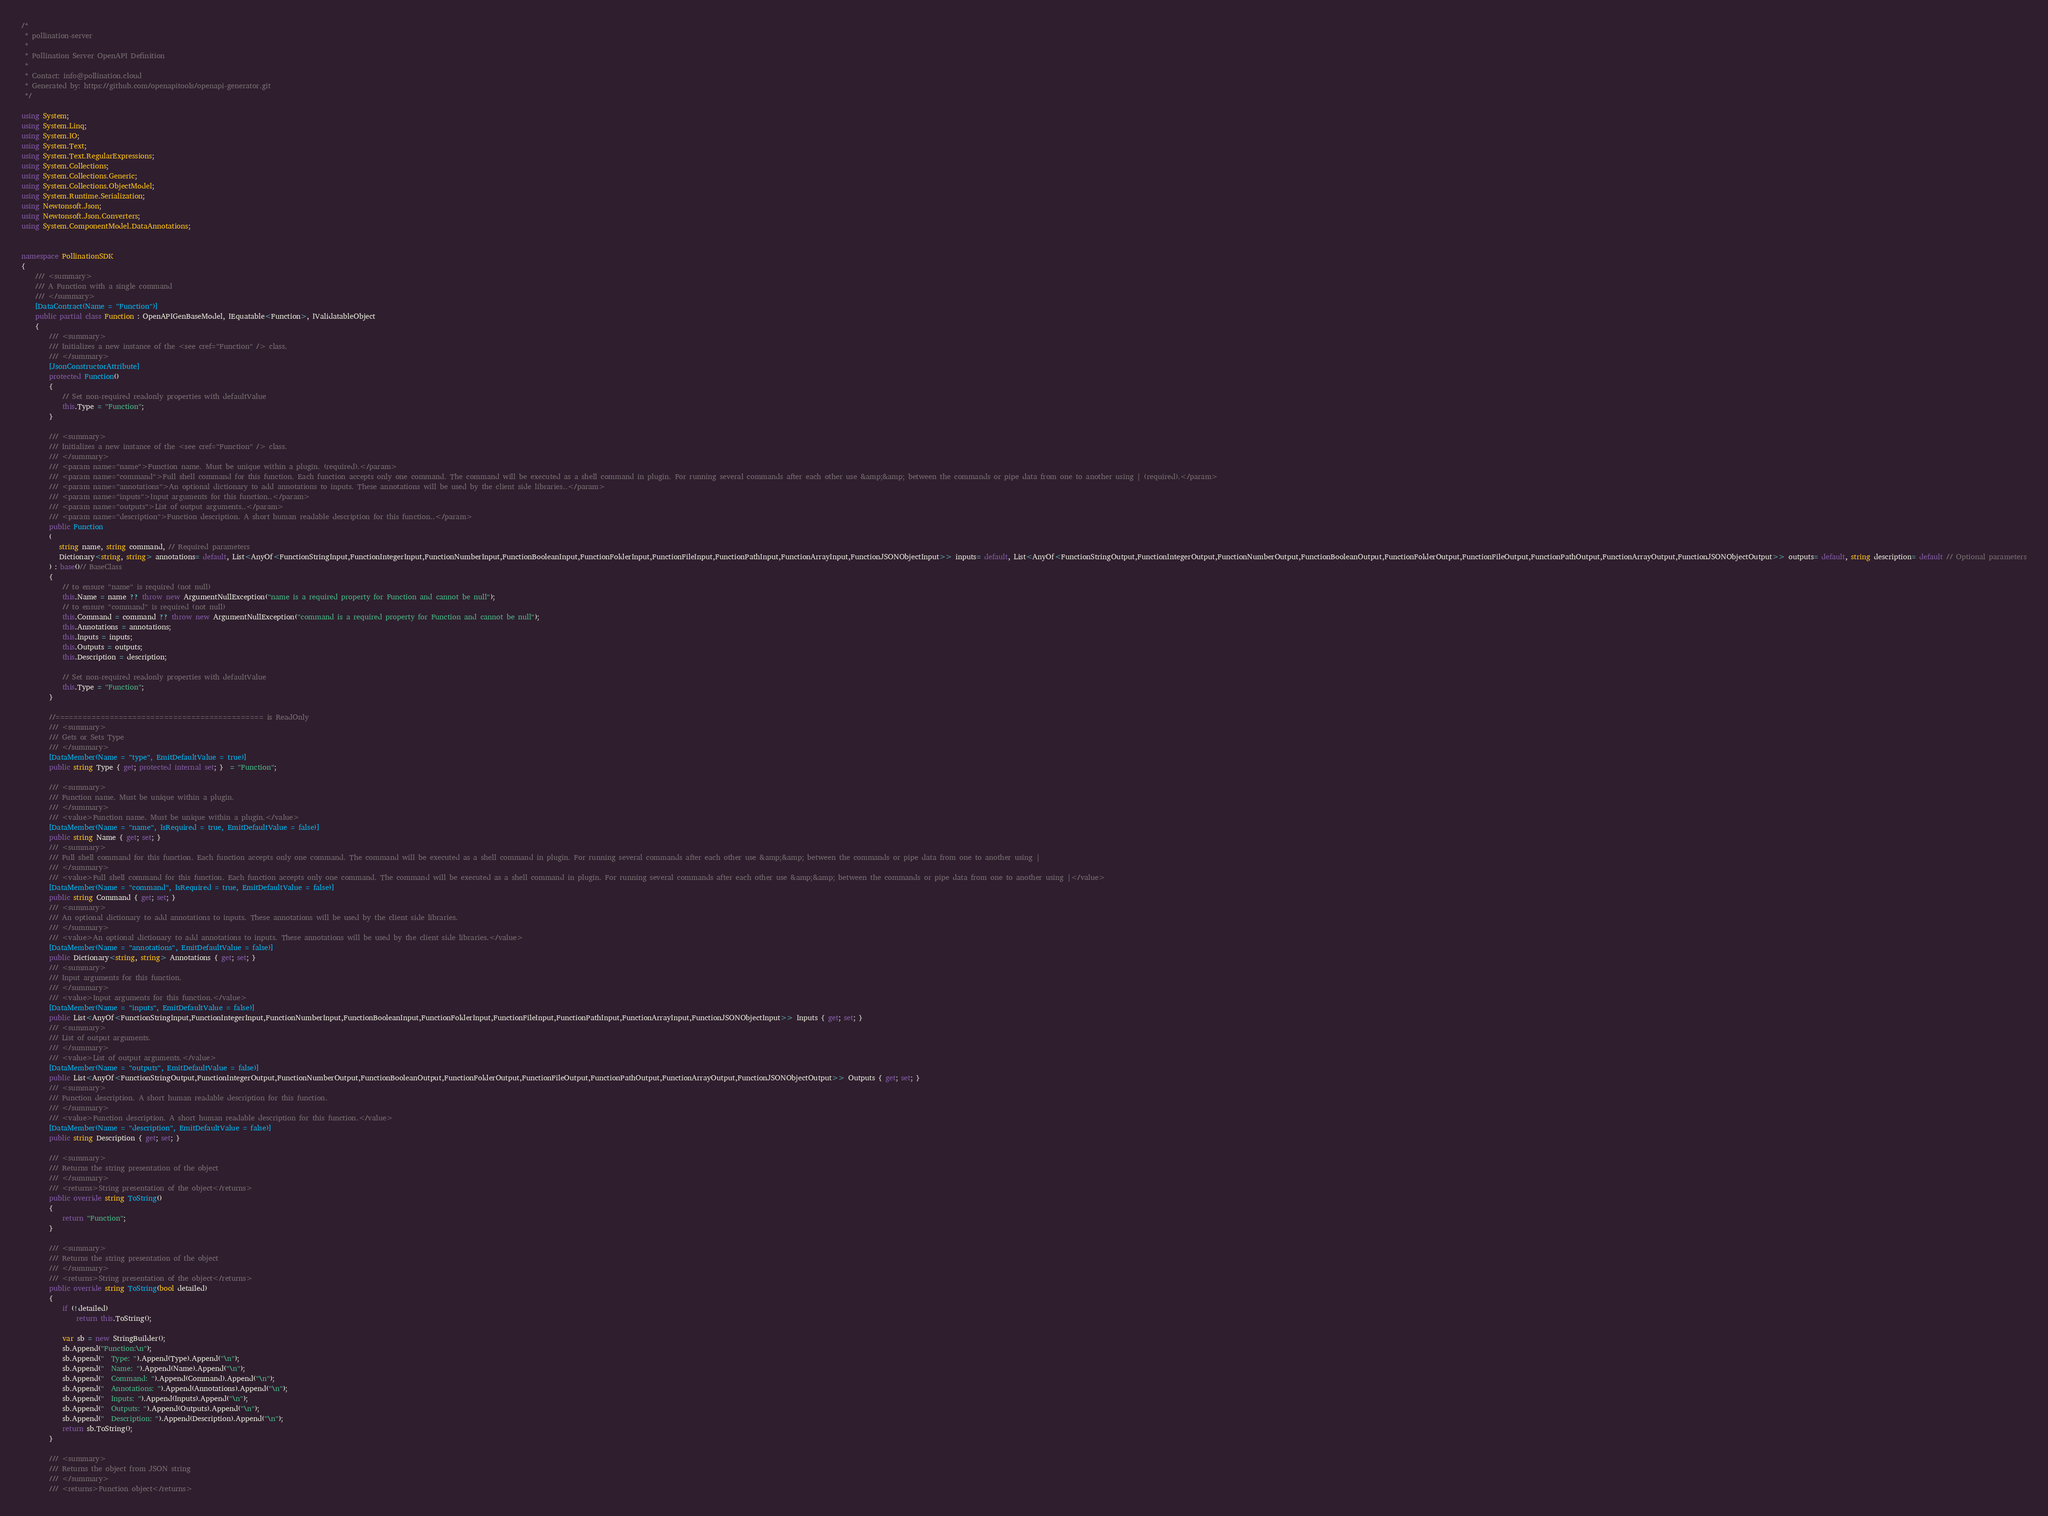<code> <loc_0><loc_0><loc_500><loc_500><_C#_>/* 
 * pollination-server
 *
 * Pollination Server OpenAPI Definition
 *
 * Contact: info@pollination.cloud
 * Generated by: https://github.com/openapitools/openapi-generator.git
 */

using System;
using System.Linq;
using System.IO;
using System.Text;
using System.Text.RegularExpressions;
using System.Collections;
using System.Collections.Generic;
using System.Collections.ObjectModel;
using System.Runtime.Serialization;
using Newtonsoft.Json;
using Newtonsoft.Json.Converters;
using System.ComponentModel.DataAnnotations;


namespace PollinationSDK
{
    /// <summary>
    /// A Function with a single command
    /// </summary>
    [DataContract(Name = "Function")]
    public partial class Function : OpenAPIGenBaseModel, IEquatable<Function>, IValidatableObject
    {
        /// <summary>
        /// Initializes a new instance of the <see cref="Function" /> class.
        /// </summary>
        [JsonConstructorAttribute]
        protected Function() 
        { 
            // Set non-required readonly properties with defaultValue
            this.Type = "Function";
        }
        
        /// <summary>
        /// Initializes a new instance of the <see cref="Function" /> class.
        /// </summary>
        /// <param name="name">Function name. Must be unique within a plugin. (required).</param>
        /// <param name="command">Full shell command for this function. Each function accepts only one command. The command will be executed as a shell command in plugin. For running several commands after each other use &amp;&amp; between the commands or pipe data from one to another using | (required).</param>
        /// <param name="annotations">An optional dictionary to add annotations to inputs. These annotations will be used by the client side libraries..</param>
        /// <param name="inputs">Input arguments for this function..</param>
        /// <param name="outputs">List of output arguments..</param>
        /// <param name="description">Function description. A short human readable description for this function..</param>
        public Function
        (
           string name, string command, // Required parameters
           Dictionary<string, string> annotations= default, List<AnyOf<FunctionStringInput,FunctionIntegerInput,FunctionNumberInput,FunctionBooleanInput,FunctionFolderInput,FunctionFileInput,FunctionPathInput,FunctionArrayInput,FunctionJSONObjectInput>> inputs= default, List<AnyOf<FunctionStringOutput,FunctionIntegerOutput,FunctionNumberOutput,FunctionBooleanOutput,FunctionFolderOutput,FunctionFileOutput,FunctionPathOutput,FunctionArrayOutput,FunctionJSONObjectOutput>> outputs= default, string description= default // Optional parameters
        ) : base()// BaseClass
        {
            // to ensure "name" is required (not null)
            this.Name = name ?? throw new ArgumentNullException("name is a required property for Function and cannot be null");
            // to ensure "command" is required (not null)
            this.Command = command ?? throw new ArgumentNullException("command is a required property for Function and cannot be null");
            this.Annotations = annotations;
            this.Inputs = inputs;
            this.Outputs = outputs;
            this.Description = description;

            // Set non-required readonly properties with defaultValue
            this.Type = "Function";
        }

        //============================================== is ReadOnly 
        /// <summary>
        /// Gets or Sets Type
        /// </summary>
        [DataMember(Name = "type", EmitDefaultValue = true)]
        public string Type { get; protected internal set; }  = "Function";

        /// <summary>
        /// Function name. Must be unique within a plugin.
        /// </summary>
        /// <value>Function name. Must be unique within a plugin.</value>
        [DataMember(Name = "name", IsRequired = true, EmitDefaultValue = false)]
        public string Name { get; set; } 
        /// <summary>
        /// Full shell command for this function. Each function accepts only one command. The command will be executed as a shell command in plugin. For running several commands after each other use &amp;&amp; between the commands or pipe data from one to another using |
        /// </summary>
        /// <value>Full shell command for this function. Each function accepts only one command. The command will be executed as a shell command in plugin. For running several commands after each other use &amp;&amp; between the commands or pipe data from one to another using |</value>
        [DataMember(Name = "command", IsRequired = true, EmitDefaultValue = false)]
        public string Command { get; set; } 
        /// <summary>
        /// An optional dictionary to add annotations to inputs. These annotations will be used by the client side libraries.
        /// </summary>
        /// <value>An optional dictionary to add annotations to inputs. These annotations will be used by the client side libraries.</value>
        [DataMember(Name = "annotations", EmitDefaultValue = false)]
        public Dictionary<string, string> Annotations { get; set; } 
        /// <summary>
        /// Input arguments for this function.
        /// </summary>
        /// <value>Input arguments for this function.</value>
        [DataMember(Name = "inputs", EmitDefaultValue = false)]
        public List<AnyOf<FunctionStringInput,FunctionIntegerInput,FunctionNumberInput,FunctionBooleanInput,FunctionFolderInput,FunctionFileInput,FunctionPathInput,FunctionArrayInput,FunctionJSONObjectInput>> Inputs { get; set; } 
        /// <summary>
        /// List of output arguments.
        /// </summary>
        /// <value>List of output arguments.</value>
        [DataMember(Name = "outputs", EmitDefaultValue = false)]
        public List<AnyOf<FunctionStringOutput,FunctionIntegerOutput,FunctionNumberOutput,FunctionBooleanOutput,FunctionFolderOutput,FunctionFileOutput,FunctionPathOutput,FunctionArrayOutput,FunctionJSONObjectOutput>> Outputs { get; set; } 
        /// <summary>
        /// Function description. A short human readable description for this function.
        /// </summary>
        /// <value>Function description. A short human readable description for this function.</value>
        [DataMember(Name = "description", EmitDefaultValue = false)]
        public string Description { get; set; } 

        /// <summary>
        /// Returns the string presentation of the object
        /// </summary>
        /// <returns>String presentation of the object</returns>
        public override string ToString()
        {
            return "Function";
        }

        /// <summary>
        /// Returns the string presentation of the object
        /// </summary>
        /// <returns>String presentation of the object</returns>
        public override string ToString(bool detailed)
        {
            if (!detailed)
                return this.ToString();
            
            var sb = new StringBuilder();
            sb.Append("Function:\n");
            sb.Append("  Type: ").Append(Type).Append("\n");
            sb.Append("  Name: ").Append(Name).Append("\n");
            sb.Append("  Command: ").Append(Command).Append("\n");
            sb.Append("  Annotations: ").Append(Annotations).Append("\n");
            sb.Append("  Inputs: ").Append(Inputs).Append("\n");
            sb.Append("  Outputs: ").Append(Outputs).Append("\n");
            sb.Append("  Description: ").Append(Description).Append("\n");
            return sb.ToString();
        }
  
        /// <summary>
        /// Returns the object from JSON string
        /// </summary>
        /// <returns>Function object</returns></code> 